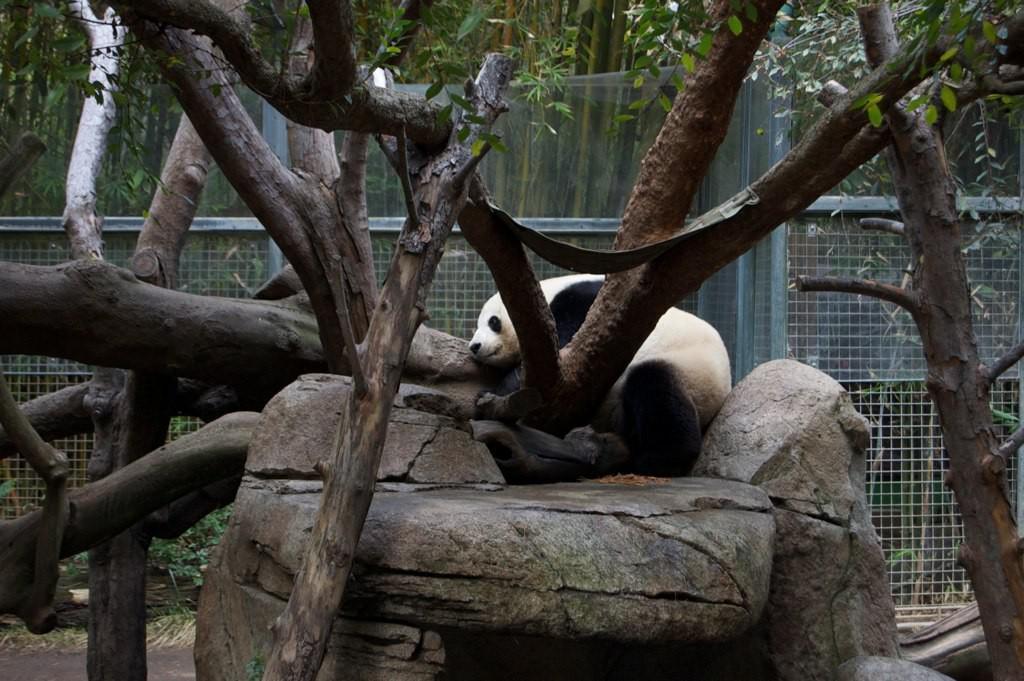Please provide a concise description of this image. In this picture there is a panda sitting on the rock and there are trees. At the back there is a fence and there are trees behind the fence. At the bottom there are plants. 